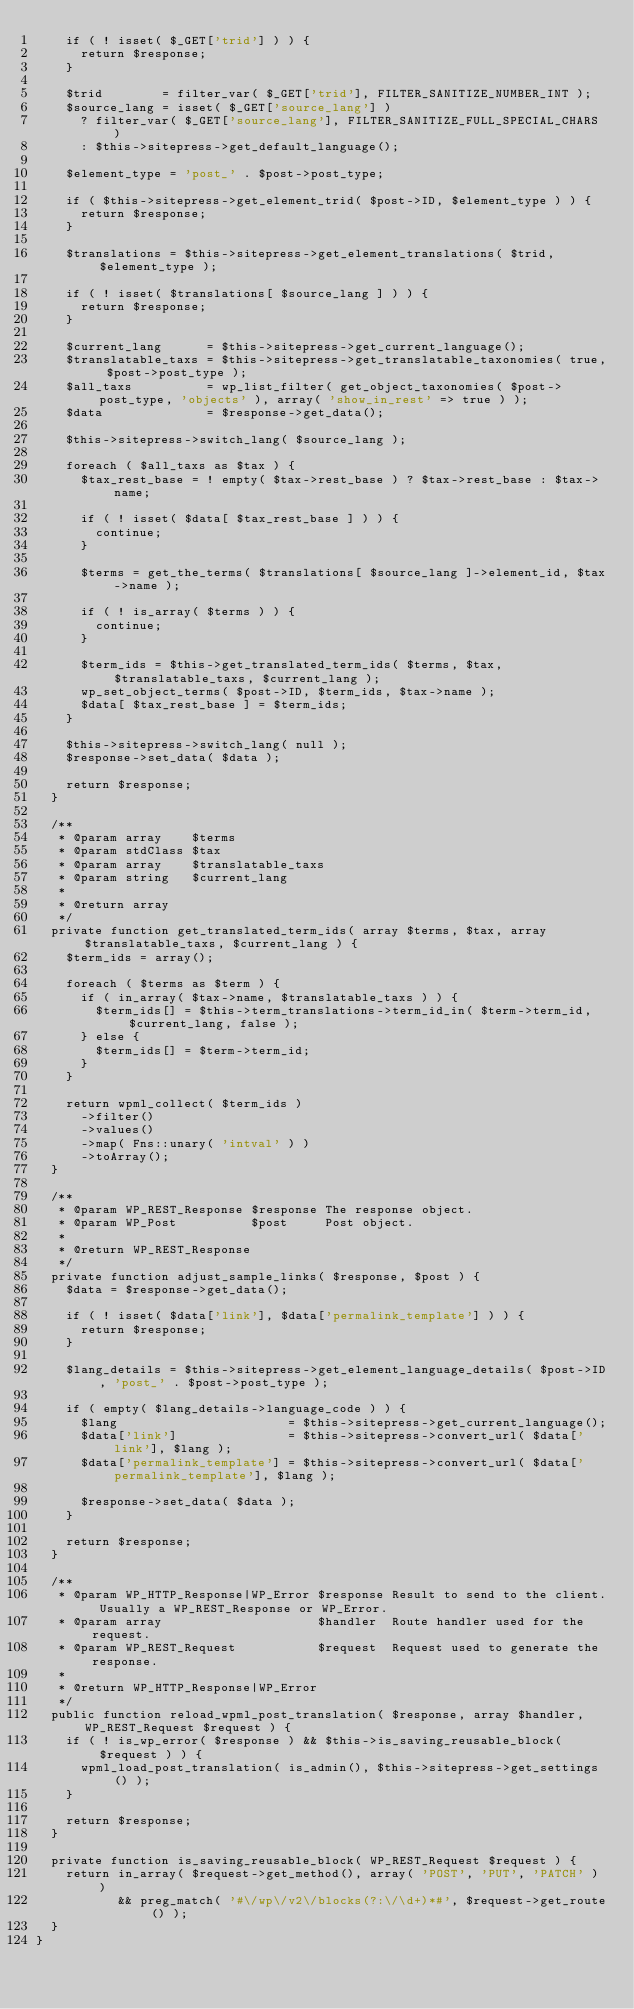<code> <loc_0><loc_0><loc_500><loc_500><_PHP_>		if ( ! isset( $_GET['trid'] ) ) {
			return $response;
		}

		$trid        = filter_var( $_GET['trid'], FILTER_SANITIZE_NUMBER_INT );
		$source_lang = isset( $_GET['source_lang'] )
			? filter_var( $_GET['source_lang'], FILTER_SANITIZE_FULL_SPECIAL_CHARS )
			: $this->sitepress->get_default_language();

		$element_type = 'post_' . $post->post_type;

		if ( $this->sitepress->get_element_trid( $post->ID, $element_type ) ) {
			return $response;
		}

		$translations = $this->sitepress->get_element_translations( $trid, $element_type );

		if ( ! isset( $translations[ $source_lang ] ) ) {
			return $response;
		}

		$current_lang      = $this->sitepress->get_current_language();
		$translatable_taxs = $this->sitepress->get_translatable_taxonomies( true, $post->post_type );
		$all_taxs          = wp_list_filter( get_object_taxonomies( $post->post_type, 'objects' ), array( 'show_in_rest' => true ) );
		$data              = $response->get_data();

		$this->sitepress->switch_lang( $source_lang );

		foreach ( $all_taxs as $tax ) {
			$tax_rest_base = ! empty( $tax->rest_base ) ? $tax->rest_base : $tax->name;

			if ( ! isset( $data[ $tax_rest_base ] ) ) {
				continue;
			}

			$terms = get_the_terms( $translations[ $source_lang ]->element_id, $tax->name );

			if ( ! is_array( $terms ) ) {
				continue;
			}

			$term_ids = $this->get_translated_term_ids( $terms, $tax, $translatable_taxs, $current_lang );
			wp_set_object_terms( $post->ID, $term_ids, $tax->name );
			$data[ $tax_rest_base ] = $term_ids;
		}

		$this->sitepress->switch_lang( null );
		$response->set_data( $data );

		return $response;
	}

	/**
	 * @param array    $terms
	 * @param stdClass $tax
	 * @param array    $translatable_taxs
	 * @param string   $current_lang
	 *
	 * @return array
	 */
	private function get_translated_term_ids( array $terms, $tax, array $translatable_taxs, $current_lang ) {
		$term_ids = array();

		foreach ( $terms as $term ) {
			if ( in_array( $tax->name, $translatable_taxs ) ) {
				$term_ids[] = $this->term_translations->term_id_in( $term->term_id, $current_lang, false );
			} else {
				$term_ids[] = $term->term_id;
			}
		}

		return wpml_collect( $term_ids )
			->filter()
			->values()
			->map( Fns::unary( 'intval' ) )
			->toArray();
	}

	/**
	 * @param WP_REST_Response $response The response object.
	 * @param WP_Post          $post     Post object.
	 *
	 * @return WP_REST_Response
	 */
	private function adjust_sample_links( $response, $post ) {
		$data = $response->get_data();

		if ( ! isset( $data['link'], $data['permalink_template'] ) ) {
			return $response;
		}

		$lang_details = $this->sitepress->get_element_language_details( $post->ID, 'post_' . $post->post_type );

		if ( empty( $lang_details->language_code ) ) {
			$lang                       = $this->sitepress->get_current_language();
			$data['link']               = $this->sitepress->convert_url( $data['link'], $lang );
			$data['permalink_template'] = $this->sitepress->convert_url( $data['permalink_template'], $lang );

			$response->set_data( $data );
		}

		return $response;
	}

	/**
	 * @param WP_HTTP_Response|WP_Error $response Result to send to the client. Usually a WP_REST_Response or WP_Error.
	 * @param array                     $handler  Route handler used for the request.
	 * @param WP_REST_Request           $request  Request used to generate the response.
	 *
	 * @return WP_HTTP_Response|WP_Error
	 */
	public function reload_wpml_post_translation( $response, array $handler, WP_REST_Request $request ) {
		if ( ! is_wp_error( $response ) && $this->is_saving_reusable_block( $request ) ) {
			wpml_load_post_translation( is_admin(), $this->sitepress->get_settings() );
		}

		return $response;
	}

	private function is_saving_reusable_block( WP_REST_Request $request ) {
		return in_array( $request->get_method(), array( 'POST', 'PUT', 'PATCH' ) )
		       && preg_match( '#\/wp\/v2\/blocks(?:\/\d+)*#', $request->get_route() );
	}
}
</code> 